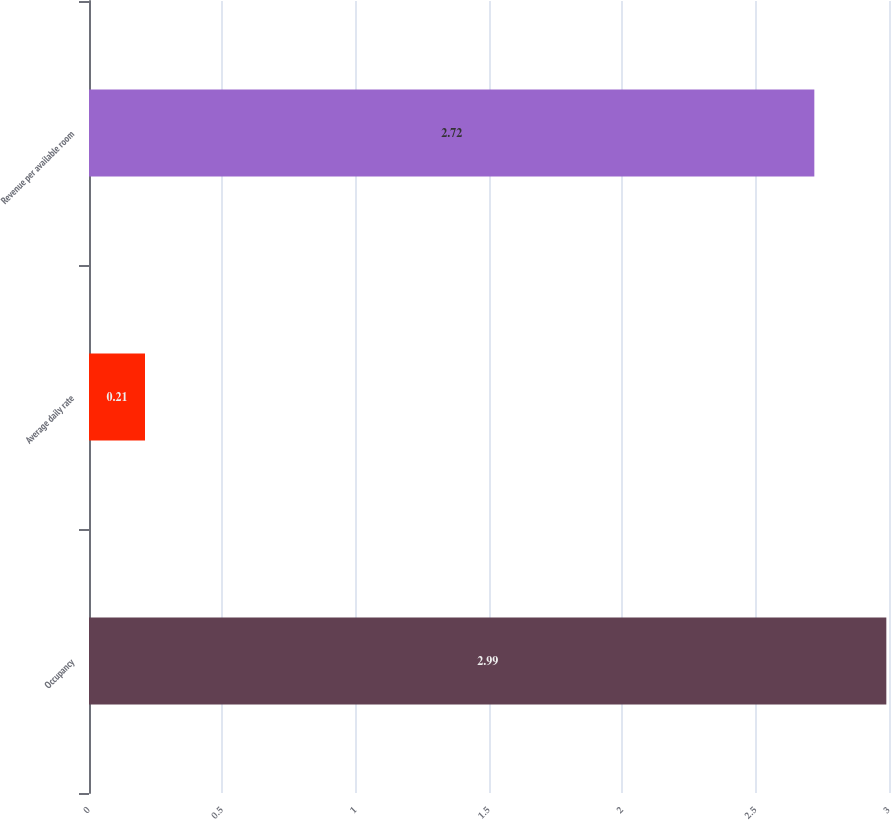Convert chart to OTSL. <chart><loc_0><loc_0><loc_500><loc_500><bar_chart><fcel>Occupancy<fcel>Average daily rate<fcel>Revenue per available room<nl><fcel>2.99<fcel>0.21<fcel>2.72<nl></chart> 